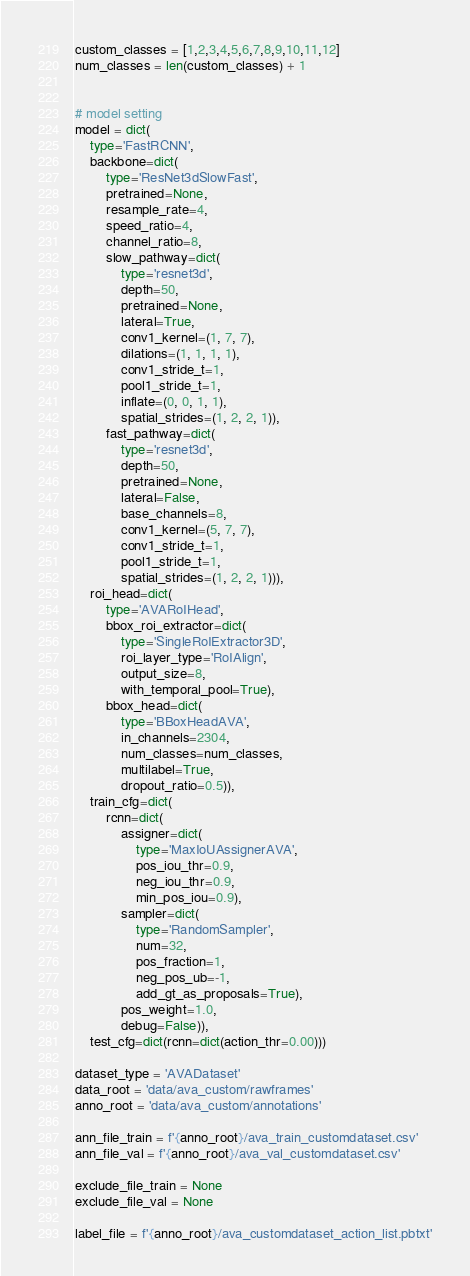<code> <loc_0><loc_0><loc_500><loc_500><_Python_>custom_classes = [1,2,3,4,5,6,7,8,9,10,11,12]
num_classes = len(custom_classes) + 1


# model setting
model = dict(
    type='FastRCNN',
    backbone=dict(
        type='ResNet3dSlowFast',
        pretrained=None,
        resample_rate=4,
        speed_ratio=4,
        channel_ratio=8,
        slow_pathway=dict(
            type='resnet3d',
            depth=50,
            pretrained=None,
            lateral=True,
            conv1_kernel=(1, 7, 7),
            dilations=(1, 1, 1, 1),
            conv1_stride_t=1,
            pool1_stride_t=1,
            inflate=(0, 0, 1, 1),
            spatial_strides=(1, 2, 2, 1)),
        fast_pathway=dict(
            type='resnet3d',
            depth=50,
            pretrained=None,
            lateral=False,
            base_channels=8,
            conv1_kernel=(5, 7, 7),
            conv1_stride_t=1,
            pool1_stride_t=1,
            spatial_strides=(1, 2, 2, 1))),
    roi_head=dict(
        type='AVARoIHead',
        bbox_roi_extractor=dict(
            type='SingleRoIExtractor3D',
            roi_layer_type='RoIAlign',
            output_size=8,
            with_temporal_pool=True),
        bbox_head=dict(
            type='BBoxHeadAVA',
            in_channels=2304,
            num_classes=num_classes,
            multilabel=True,
            dropout_ratio=0.5)),
    train_cfg=dict(
        rcnn=dict(
            assigner=dict(
                type='MaxIoUAssignerAVA',
                pos_iou_thr=0.9,
                neg_iou_thr=0.9,
                min_pos_iou=0.9),
            sampler=dict(
                type='RandomSampler',
                num=32,
                pos_fraction=1,
                neg_pos_ub=-1,
                add_gt_as_proposals=True),
            pos_weight=1.0,
            debug=False)),
    test_cfg=dict(rcnn=dict(action_thr=0.00)))

dataset_type = 'AVADataset'
data_root = 'data/ava_custom/rawframes'
anno_root = 'data/ava_custom/annotations'

ann_file_train = f'{anno_root}/ava_train_customdataset.csv'
ann_file_val = f'{anno_root}/ava_val_customdataset.csv'

exclude_file_train = None
exclude_file_val = None

label_file = f'{anno_root}/ava_customdataset_action_list.pbtxt'
</code> 